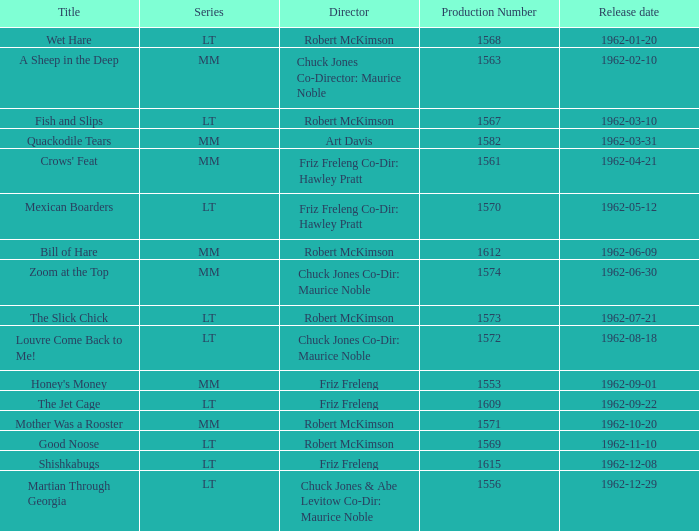Help me parse the entirety of this table. {'header': ['Title', 'Series', 'Director', 'Production Number', 'Release date'], 'rows': [['Wet Hare', 'LT', 'Robert McKimson', '1568', '1962-01-20'], ['A Sheep in the Deep', 'MM', 'Chuck Jones Co-Director: Maurice Noble', '1563', '1962-02-10'], ['Fish and Slips', 'LT', 'Robert McKimson', '1567', '1962-03-10'], ['Quackodile Tears', 'MM', 'Art Davis', '1582', '1962-03-31'], ["Crows' Feat", 'MM', 'Friz Freleng Co-Dir: Hawley Pratt', '1561', '1962-04-21'], ['Mexican Boarders', 'LT', 'Friz Freleng Co-Dir: Hawley Pratt', '1570', '1962-05-12'], ['Bill of Hare', 'MM', 'Robert McKimson', '1612', '1962-06-09'], ['Zoom at the Top', 'MM', 'Chuck Jones Co-Dir: Maurice Noble', '1574', '1962-06-30'], ['The Slick Chick', 'LT', 'Robert McKimson', '1573', '1962-07-21'], ['Louvre Come Back to Me!', 'LT', 'Chuck Jones Co-Dir: Maurice Noble', '1572', '1962-08-18'], ["Honey's Money", 'MM', 'Friz Freleng', '1553', '1962-09-01'], ['The Jet Cage', 'LT', 'Friz Freleng', '1609', '1962-09-22'], ['Mother Was a Rooster', 'MM', 'Robert McKimson', '1571', '1962-10-20'], ['Good Noose', 'LT', 'Robert McKimson', '1569', '1962-11-10'], ['Shishkabugs', 'LT', 'Friz Freleng', '1615', '1962-12-08'], ['Martian Through Georgia', 'LT', 'Chuck Jones & Abe Levitow Co-Dir: Maurice Noble', '1556', '1962-12-29']]} What is Crows' Feat's production number? 1561.0. 